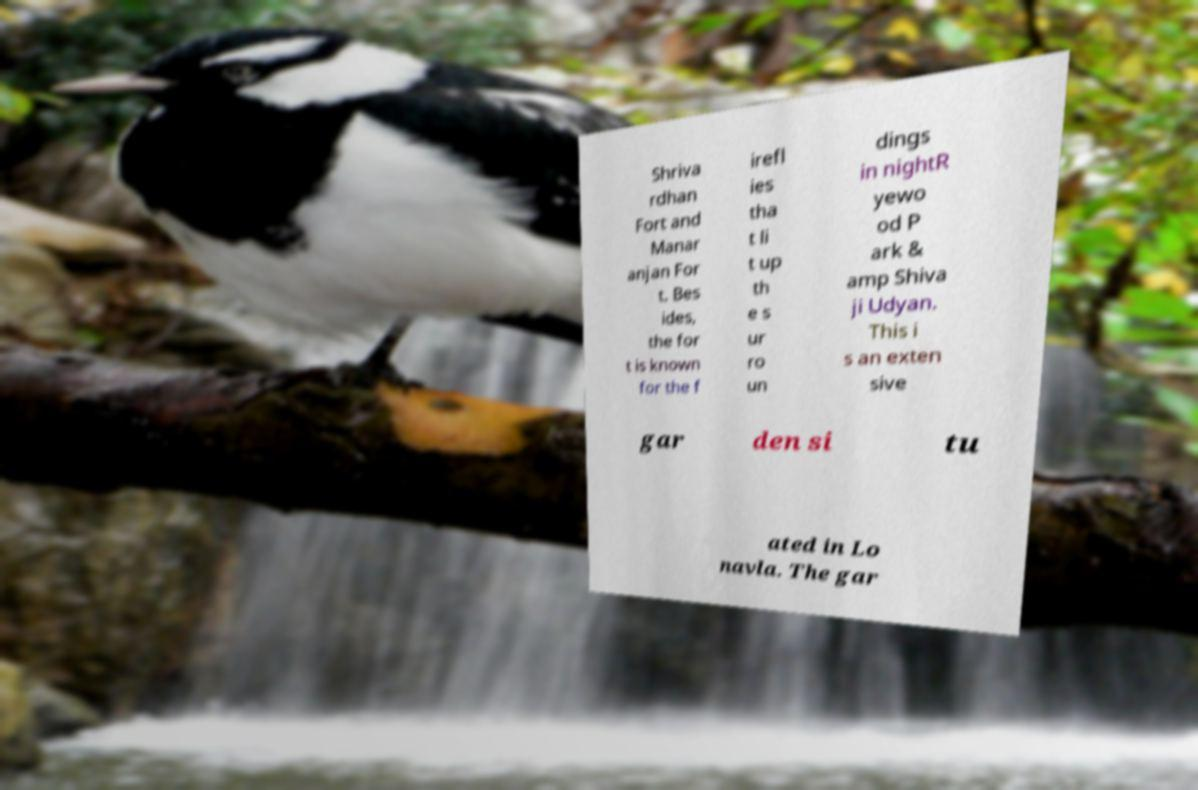Please identify and transcribe the text found in this image. Shriva rdhan Fort and Manar anjan For t. Bes ides, the for t is known for the f irefl ies tha t li t up th e s ur ro un dings in nightR yewo od P ark & amp Shiva ji Udyan. This i s an exten sive gar den si tu ated in Lo navla. The gar 